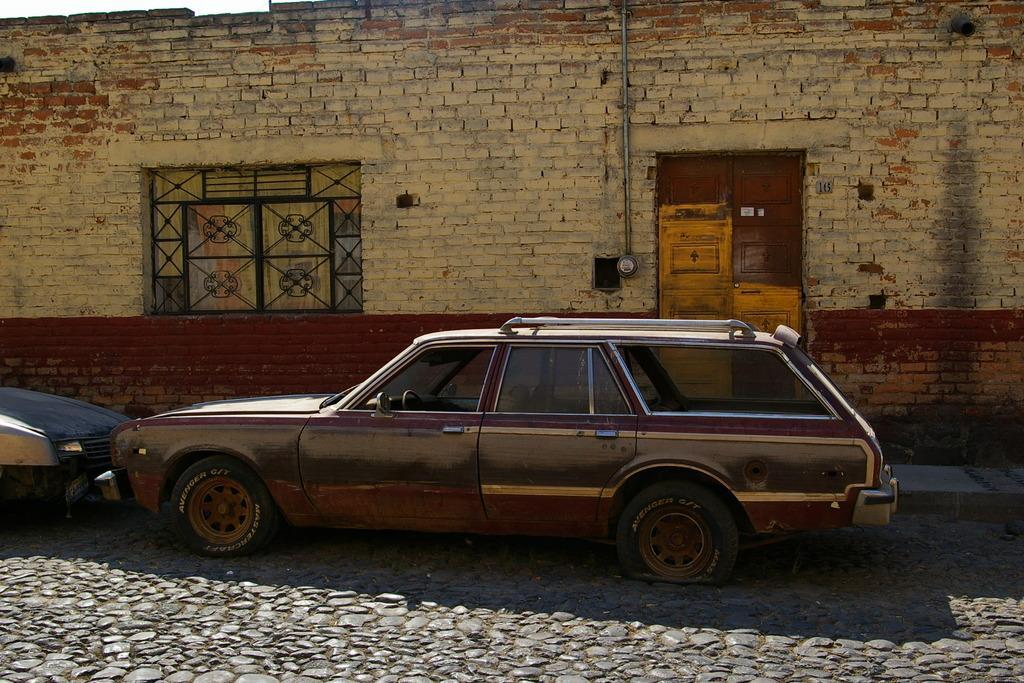Please provide a concise description of this image. In this picture we can see two vehicles parked on the road. Behind the vehicles, there is a house with a door, window and a pipe. 